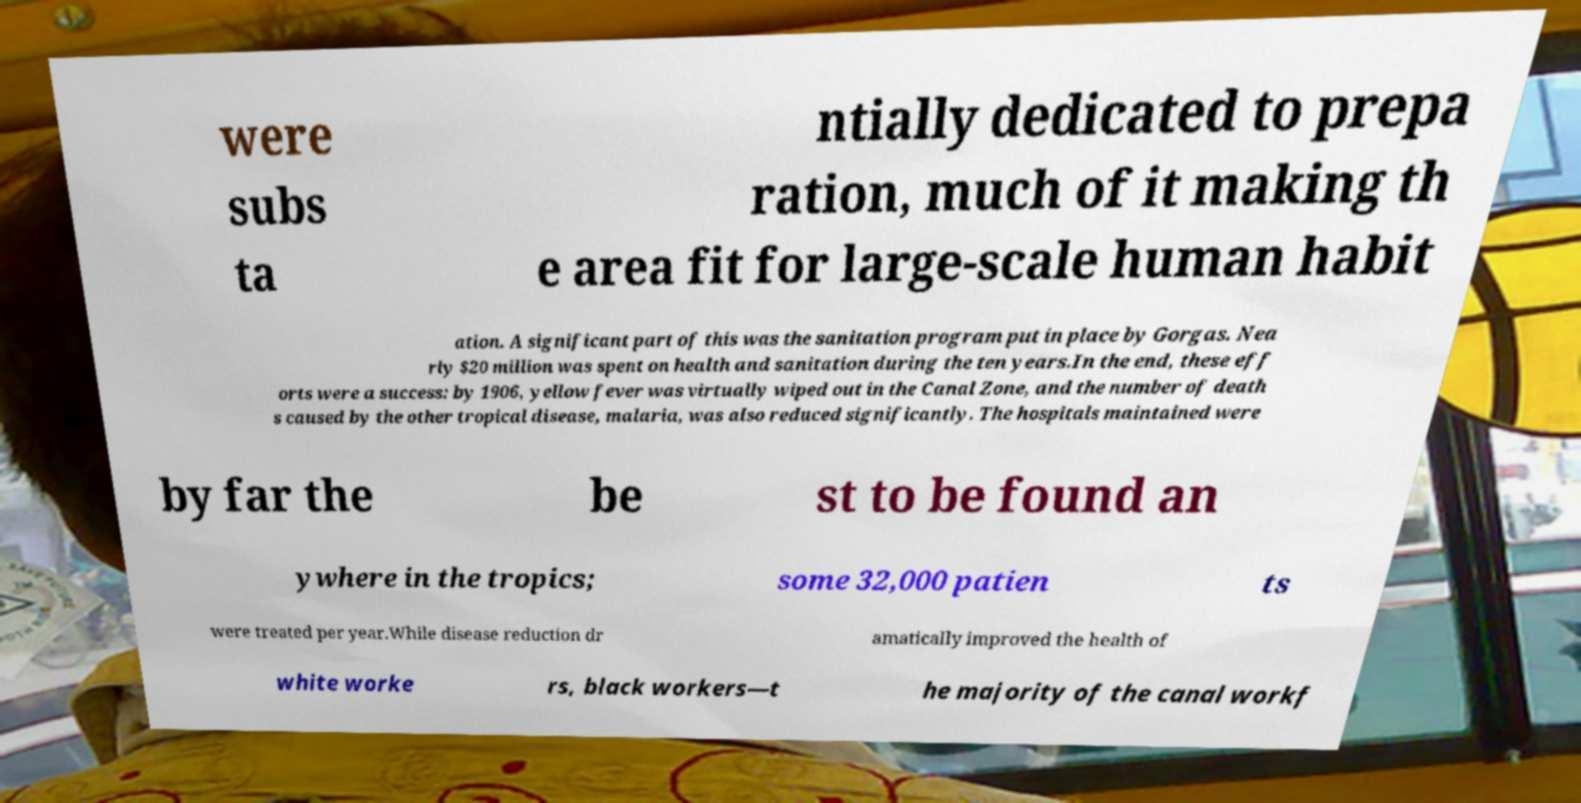For documentation purposes, I need the text within this image transcribed. Could you provide that? were subs ta ntially dedicated to prepa ration, much of it making th e area fit for large-scale human habit ation. A significant part of this was the sanitation program put in place by Gorgas. Nea rly $20 million was spent on health and sanitation during the ten years.In the end, these eff orts were a success: by 1906, yellow fever was virtually wiped out in the Canal Zone, and the number of death s caused by the other tropical disease, malaria, was also reduced significantly. The hospitals maintained were by far the be st to be found an ywhere in the tropics; some 32,000 patien ts were treated per year.While disease reduction dr amatically improved the health of white worke rs, black workers—t he majority of the canal workf 